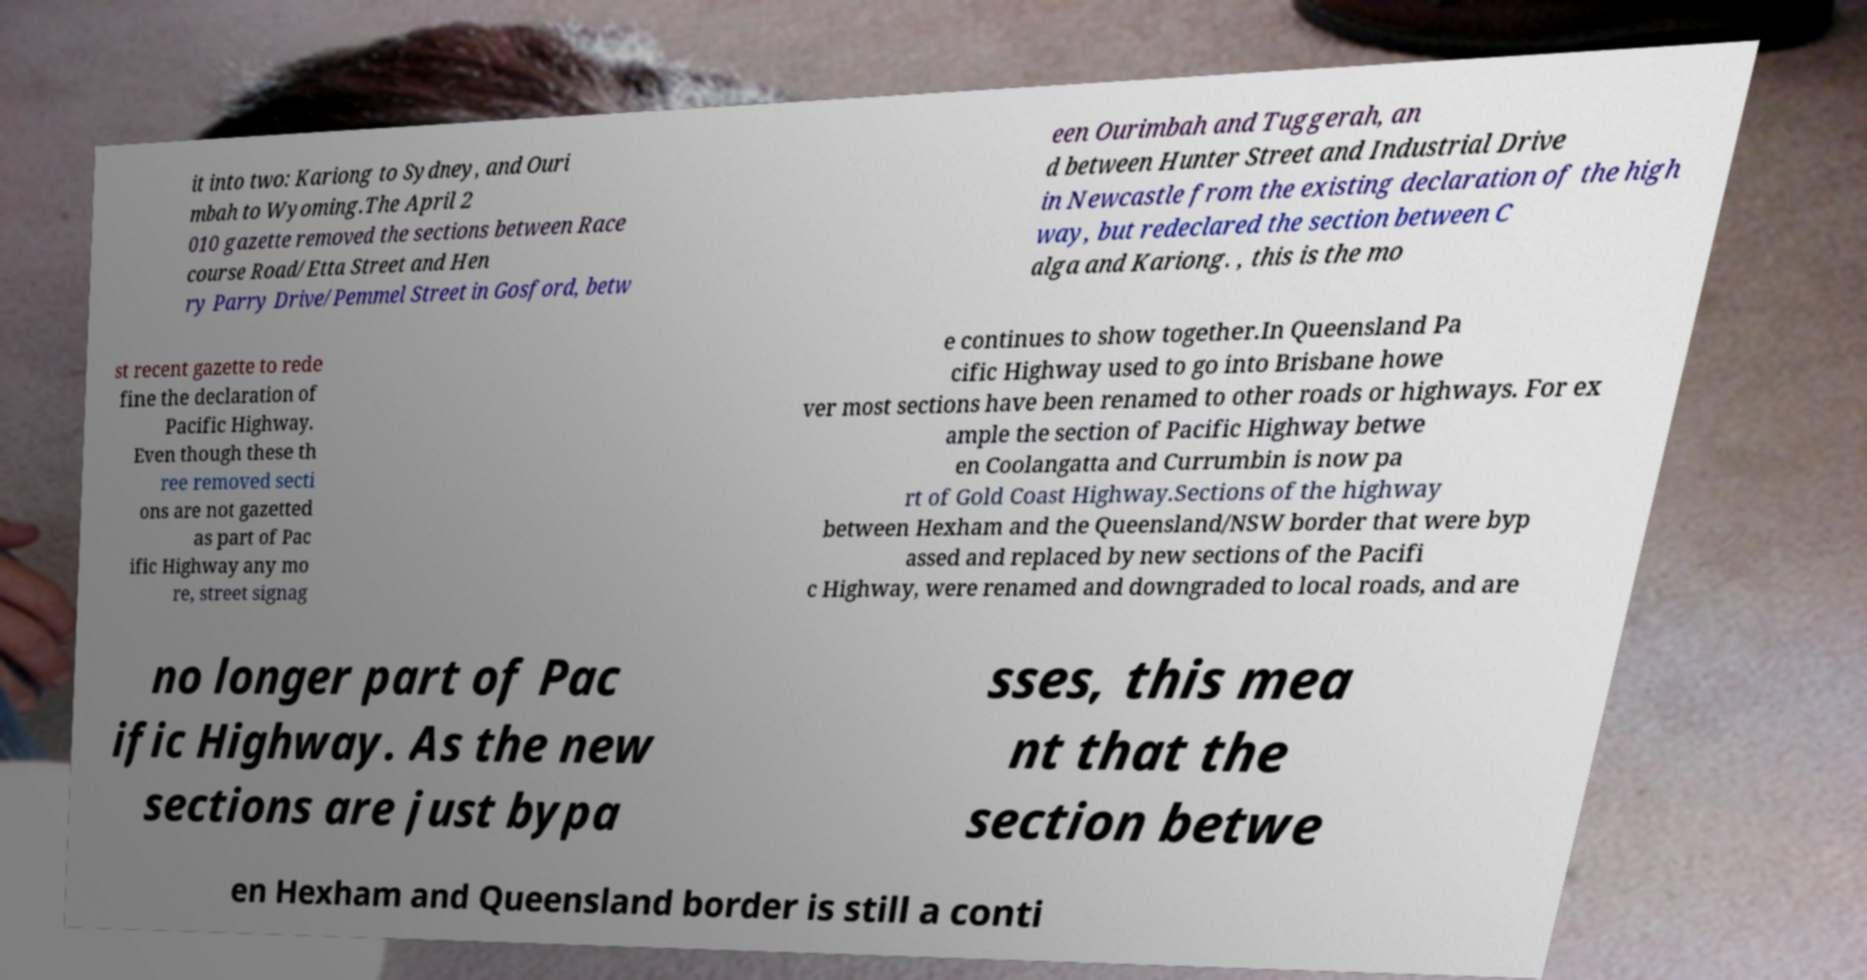There's text embedded in this image that I need extracted. Can you transcribe it verbatim? it into two: Kariong to Sydney, and Ouri mbah to Wyoming.The April 2 010 gazette removed the sections between Race course Road/Etta Street and Hen ry Parry Drive/Pemmel Street in Gosford, betw een Ourimbah and Tuggerah, an d between Hunter Street and Industrial Drive in Newcastle from the existing declaration of the high way, but redeclared the section between C alga and Kariong. , this is the mo st recent gazette to rede fine the declaration of Pacific Highway. Even though these th ree removed secti ons are not gazetted as part of Pac ific Highway any mo re, street signag e continues to show together.In Queensland Pa cific Highway used to go into Brisbane howe ver most sections have been renamed to other roads or highways. For ex ample the section of Pacific Highway betwe en Coolangatta and Currumbin is now pa rt of Gold Coast Highway.Sections of the highway between Hexham and the Queensland/NSW border that were byp assed and replaced by new sections of the Pacifi c Highway, were renamed and downgraded to local roads, and are no longer part of Pac ific Highway. As the new sections are just bypa sses, this mea nt that the section betwe en Hexham and Queensland border is still a conti 